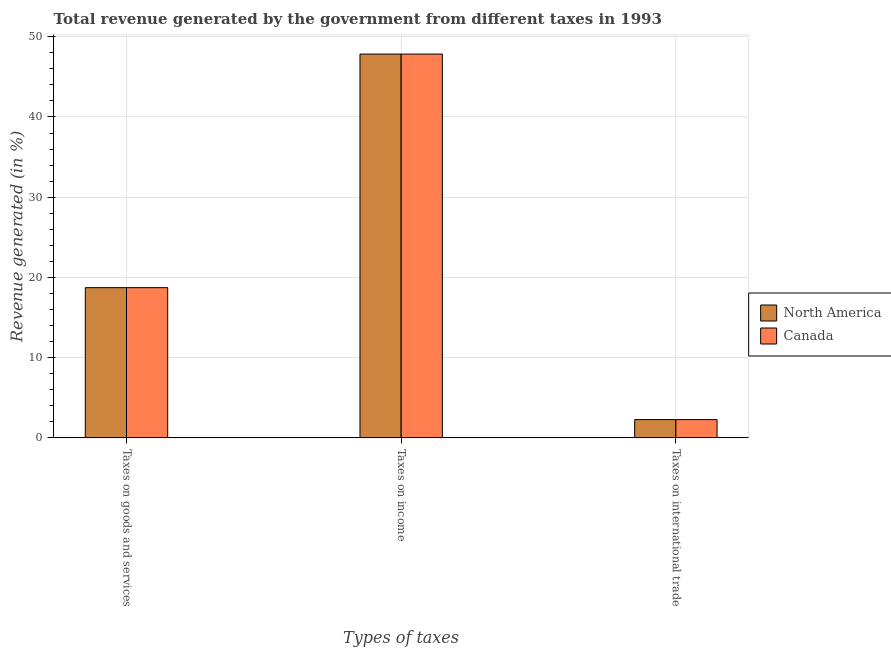How many groups of bars are there?
Your answer should be very brief. 3. Are the number of bars on each tick of the X-axis equal?
Offer a terse response. Yes. What is the label of the 3rd group of bars from the left?
Your answer should be compact. Taxes on international trade. What is the percentage of revenue generated by taxes on income in North America?
Offer a terse response. 47.84. Across all countries, what is the maximum percentage of revenue generated by taxes on goods and services?
Your answer should be compact. 18.72. Across all countries, what is the minimum percentage of revenue generated by taxes on goods and services?
Your answer should be very brief. 18.72. What is the total percentage of revenue generated by taxes on goods and services in the graph?
Make the answer very short. 37.44. What is the difference between the percentage of revenue generated by taxes on goods and services in Canada and that in North America?
Your answer should be compact. 0. What is the difference between the percentage of revenue generated by taxes on goods and services in North America and the percentage of revenue generated by tax on international trade in Canada?
Your response must be concise. 16.44. What is the average percentage of revenue generated by taxes on goods and services per country?
Give a very brief answer. 18.72. What is the difference between the percentage of revenue generated by tax on international trade and percentage of revenue generated by taxes on goods and services in North America?
Your response must be concise. -16.44. What does the 1st bar from the left in Taxes on income represents?
Provide a succinct answer. North America. How many bars are there?
Provide a succinct answer. 6. How many countries are there in the graph?
Offer a very short reply. 2. What is the difference between two consecutive major ticks on the Y-axis?
Your answer should be very brief. 10. Are the values on the major ticks of Y-axis written in scientific E-notation?
Give a very brief answer. No. Does the graph contain grids?
Your answer should be very brief. Yes. What is the title of the graph?
Your answer should be compact. Total revenue generated by the government from different taxes in 1993. What is the label or title of the X-axis?
Offer a very short reply. Types of taxes. What is the label or title of the Y-axis?
Your response must be concise. Revenue generated (in %). What is the Revenue generated (in %) in North America in Taxes on goods and services?
Ensure brevity in your answer.  18.72. What is the Revenue generated (in %) in Canada in Taxes on goods and services?
Your response must be concise. 18.72. What is the Revenue generated (in %) of North America in Taxes on income?
Provide a short and direct response. 47.84. What is the Revenue generated (in %) of Canada in Taxes on income?
Your answer should be very brief. 47.84. What is the Revenue generated (in %) of North America in Taxes on international trade?
Offer a very short reply. 2.28. What is the Revenue generated (in %) of Canada in Taxes on international trade?
Provide a short and direct response. 2.28. Across all Types of taxes, what is the maximum Revenue generated (in %) of North America?
Ensure brevity in your answer.  47.84. Across all Types of taxes, what is the maximum Revenue generated (in %) in Canada?
Provide a succinct answer. 47.84. Across all Types of taxes, what is the minimum Revenue generated (in %) in North America?
Make the answer very short. 2.28. Across all Types of taxes, what is the minimum Revenue generated (in %) in Canada?
Ensure brevity in your answer.  2.28. What is the total Revenue generated (in %) in North America in the graph?
Your answer should be very brief. 68.84. What is the total Revenue generated (in %) of Canada in the graph?
Provide a succinct answer. 68.84. What is the difference between the Revenue generated (in %) of North America in Taxes on goods and services and that in Taxes on income?
Make the answer very short. -29.12. What is the difference between the Revenue generated (in %) of Canada in Taxes on goods and services and that in Taxes on income?
Give a very brief answer. -29.12. What is the difference between the Revenue generated (in %) in North America in Taxes on goods and services and that in Taxes on international trade?
Offer a terse response. 16.44. What is the difference between the Revenue generated (in %) of Canada in Taxes on goods and services and that in Taxes on international trade?
Provide a short and direct response. 16.44. What is the difference between the Revenue generated (in %) of North America in Taxes on income and that in Taxes on international trade?
Offer a terse response. 45.56. What is the difference between the Revenue generated (in %) of Canada in Taxes on income and that in Taxes on international trade?
Your answer should be compact. 45.56. What is the difference between the Revenue generated (in %) in North America in Taxes on goods and services and the Revenue generated (in %) in Canada in Taxes on income?
Offer a very short reply. -29.12. What is the difference between the Revenue generated (in %) in North America in Taxes on goods and services and the Revenue generated (in %) in Canada in Taxes on international trade?
Your response must be concise. 16.44. What is the difference between the Revenue generated (in %) of North America in Taxes on income and the Revenue generated (in %) of Canada in Taxes on international trade?
Offer a terse response. 45.56. What is the average Revenue generated (in %) of North America per Types of taxes?
Make the answer very short. 22.95. What is the average Revenue generated (in %) in Canada per Types of taxes?
Provide a succinct answer. 22.95. What is the difference between the Revenue generated (in %) of North America and Revenue generated (in %) of Canada in Taxes on income?
Keep it short and to the point. 0. What is the ratio of the Revenue generated (in %) in North America in Taxes on goods and services to that in Taxes on income?
Provide a short and direct response. 0.39. What is the ratio of the Revenue generated (in %) in Canada in Taxes on goods and services to that in Taxes on income?
Make the answer very short. 0.39. What is the ratio of the Revenue generated (in %) in North America in Taxes on goods and services to that in Taxes on international trade?
Your response must be concise. 8.22. What is the ratio of the Revenue generated (in %) of Canada in Taxes on goods and services to that in Taxes on international trade?
Ensure brevity in your answer.  8.22. What is the ratio of the Revenue generated (in %) in North America in Taxes on income to that in Taxes on international trade?
Keep it short and to the point. 21.01. What is the ratio of the Revenue generated (in %) of Canada in Taxes on income to that in Taxes on international trade?
Your response must be concise. 21.01. What is the difference between the highest and the second highest Revenue generated (in %) in North America?
Give a very brief answer. 29.12. What is the difference between the highest and the second highest Revenue generated (in %) in Canada?
Your answer should be very brief. 29.12. What is the difference between the highest and the lowest Revenue generated (in %) of North America?
Offer a terse response. 45.56. What is the difference between the highest and the lowest Revenue generated (in %) in Canada?
Your answer should be compact. 45.56. 